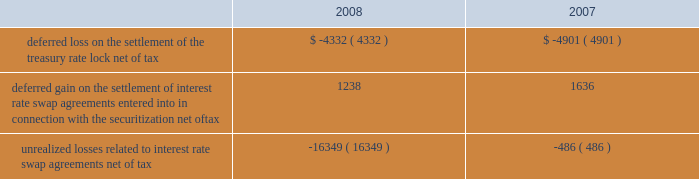American tower corporation and subsidiaries notes to consolidated financial statements 2014 ( continued ) of certain of its assets and liabilities under its interest rate swap agreements held as of december 31 , 2006 and entered into during the first half of 2007 .
In addition , the company paid $ 8.0 million related to a treasury rate lock agreement entered into and settled during the year ended december 31 , 2008 .
The cost of the treasury rate lock is being recognized as additional interest expense over the 10-year term of the 7.00% ( 7.00 % ) notes .
During the year ended december 31 , 2007 , the company also received $ 3.1 million in cash upon settlement of the assets and liabilities under ten forward starting interest rate swap agreements with an aggregate notional amount of $ 1.4 billion , which were designated as cash flow hedges to manage exposure to variability in cash flows relating to forecasted interest payments in connection with the certificates issued in the securitization in may 2007 .
The settlement is being recognized as a reduction in interest expense over the five-year period for which the interest rate swaps were designated as hedges .
The company also received $ 17.0 million in cash upon settlement of the assets and liabilities under thirteen additional interest rate swap agreements with an aggregate notional amount of $ 850.0 million that managed exposure to variability of interest rates under the credit facilities but were not considered cash flow hedges for accounting purposes .
This gain is included in other income in the accompanying consolidated statement of operations for the year ended december 31 , 2007 .
As of december 31 , 2008 and 2007 , other comprehensive ( loss ) income included the following items related to derivative financial instruments ( in thousands ) : .
During the years ended december 31 , 2008 and 2007 , the company recorded an aggregate net unrealized loss of approximately $ 15.8 million and $ 3.2 million , respectively ( net of a tax provision of approximately $ 10.2 million and $ 2.0 million , respectively ) in other comprehensive loss for the change in fair value of interest rate swaps designated as cash flow hedges and reclassified an aggregate of $ 0.1 million and $ 6.2 million , respectively ( net of an income tax provision of $ 2.0 million and an income tax benefit of $ 3.3 million , respectively ) into results of operations .
Fair valuemeasurements the company determines the fair market values of its financial instruments based on the fair value hierarchy established in sfas no .
157 , which requires an entity to maximize the use of observable inputs and minimize the use of unobservable inputs when measuring fair value .
The standard describes three levels of inputs that may be used to measure fair value .
Level 1 quoted prices in active markets for identical assets or liabilities that the company has the ability to access at the measurement date .
The company 2019s level 1 assets consist of available-for-sale securities traded on active markets as well as certain brazilian treasury securities that are highly liquid and are actively traded in over-the-counter markets .
Level 2 observable inputs other than level 1 prices , such as quoted prices for similar assets or liabilities ; quoted prices in markets that are not active ; or other inputs that are observable or can be corroborated by observable market data for substantially the full term of the assets or liabilities. .
What was the change in the unrealized losses related to interest rate swap agreements net of tax from 2007 to 2008? 
Computations: (-16349 - -486)
Answer: -15863.0. 